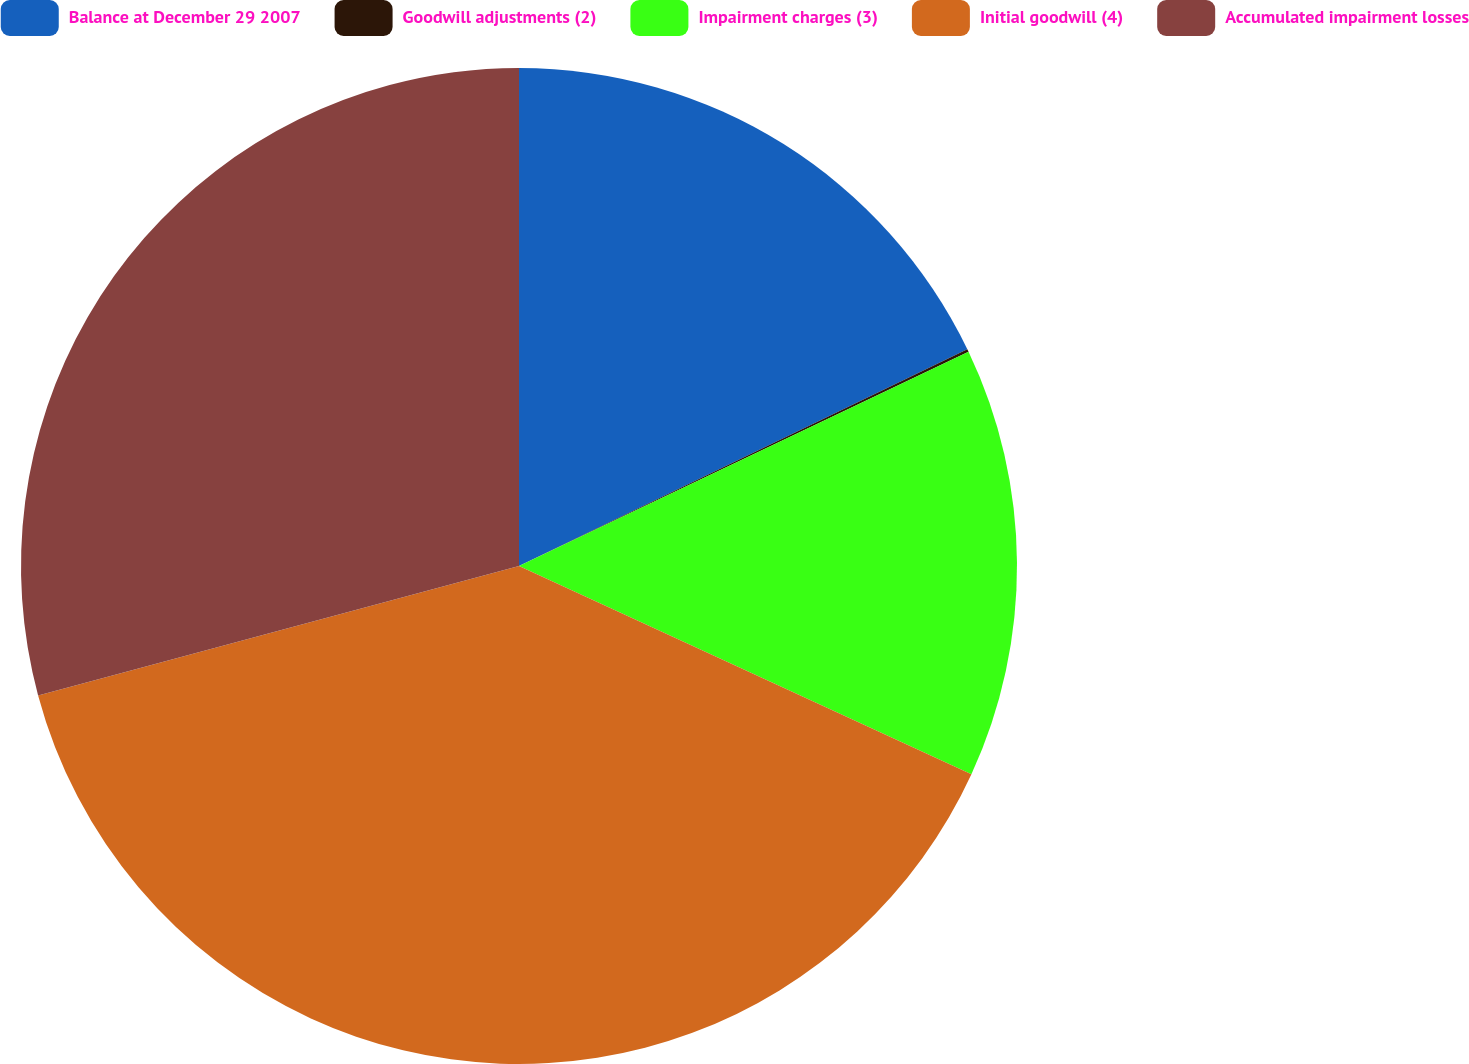<chart> <loc_0><loc_0><loc_500><loc_500><pie_chart><fcel>Balance at December 29 2007<fcel>Goodwill adjustments (2)<fcel>Impairment charges (3)<fcel>Initial goodwill (4)<fcel>Accumulated impairment losses<nl><fcel>17.83%<fcel>0.09%<fcel>13.94%<fcel>38.95%<fcel>29.18%<nl></chart> 